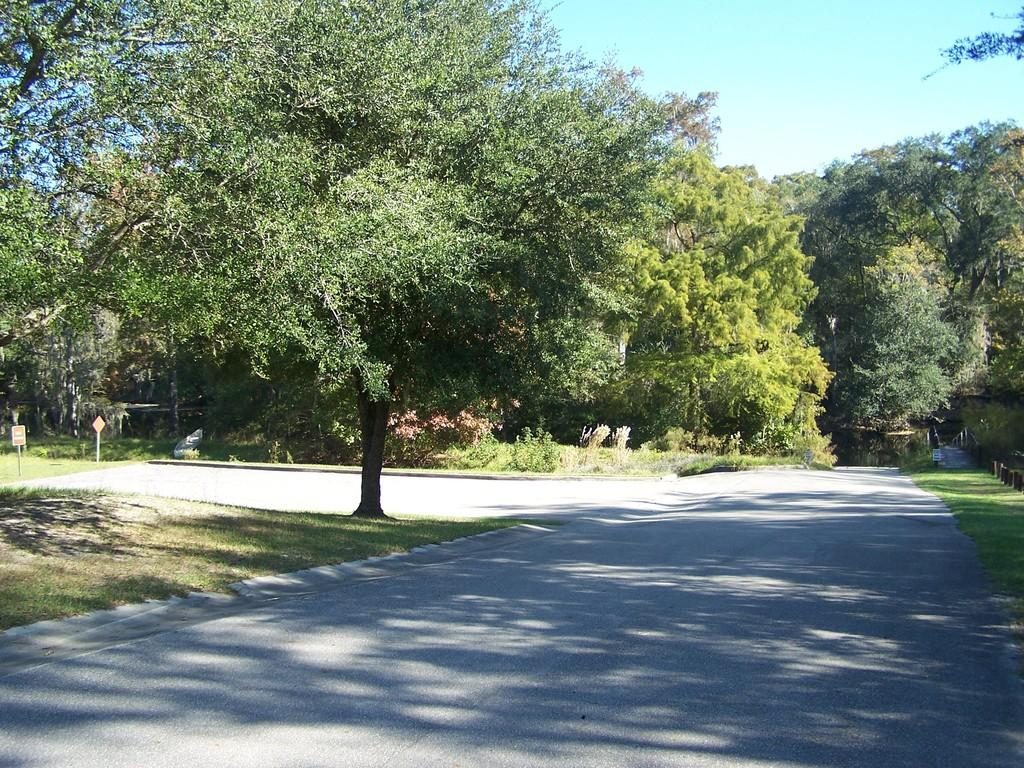What is the main feature of the image? There is a road in the image. What can be seen in the background of the image? There are trees and sign boards in the background of the image. What is visible above the trees and sign boards? The sky is visible in the background of the image. Can you see an owl sitting on the sign board in the image? There is no owl present in the image. What type of chalk is being used to write on the road in the image? There is no chalk or writing on the road in the image. 